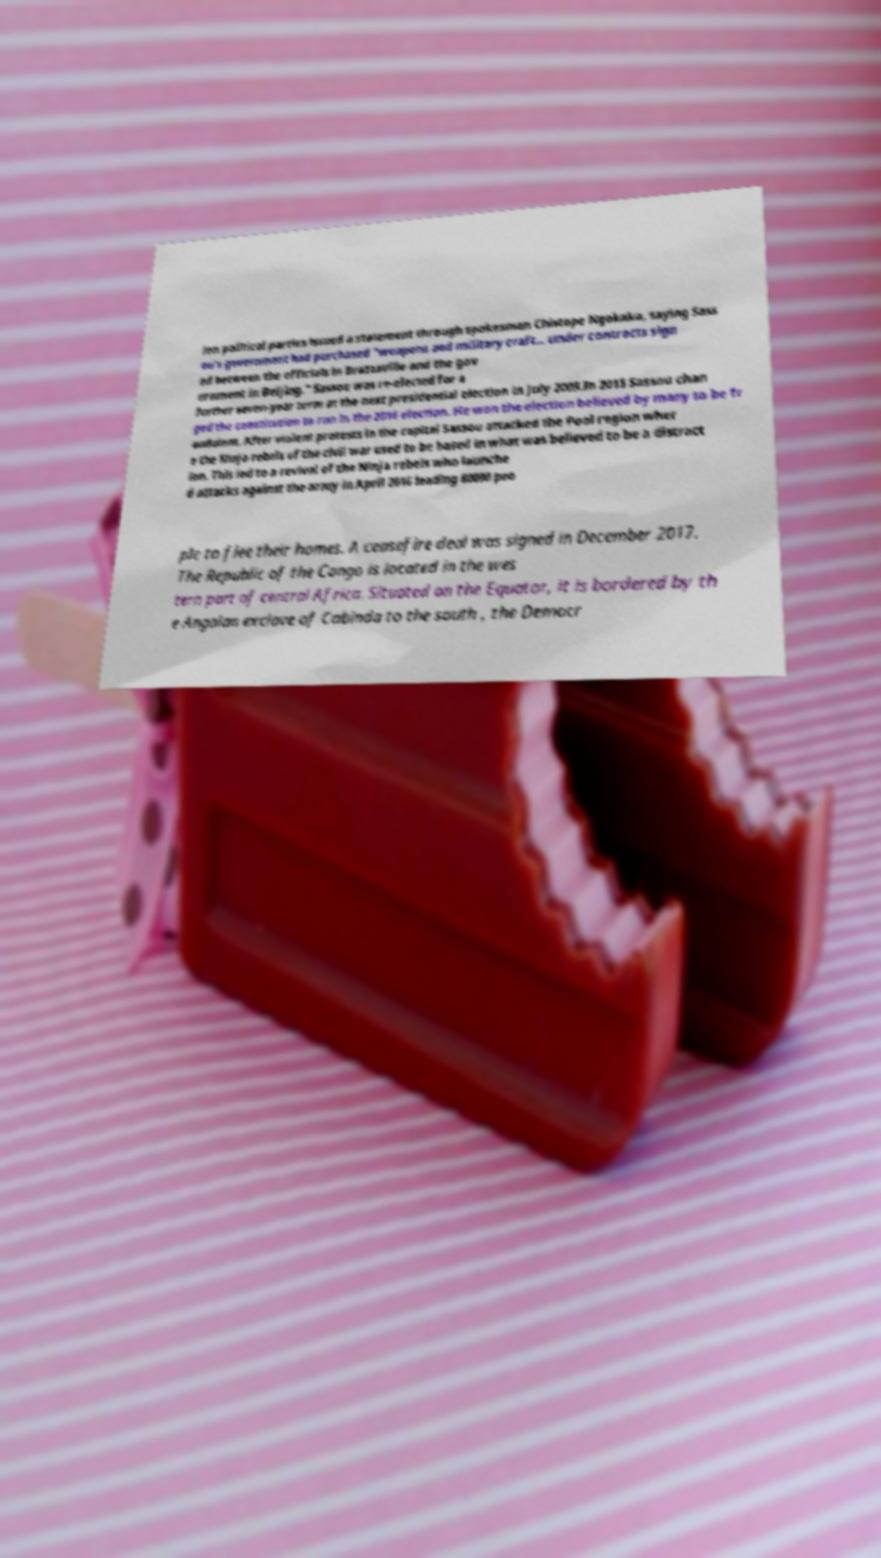Can you accurately transcribe the text from the provided image for me? ion political parties issued a statement through spokesman Chistope Ngokaka, saying Sass ou's government had purchased "weapons and military craft... under contracts sign ed between the officials in Brazzaville and the gov ernment in Beijing." Sassou was re-elected for a further seven-year term at the next presidential election in July 2009.In 2015 Sassou chan ged the constitution to run in the 2016 election. He won the election believed by many to be fr audulent. After violent protests in the capital Sassou attacked the Pool region wher e the Ninja rebels of the civil war used to be based in what was believed to be a distract ion. This led to a revival of the Ninja rebels who launche d attacks against the army in April 2016 leading 80000 peo ple to flee their homes. A ceasefire deal was signed in December 2017. The Republic of the Congo is located in the wes tern part of central Africa. Situated on the Equator, it is bordered by th e Angolan exclave of Cabinda to the south , the Democr 